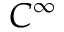Convert formula to latex. <formula><loc_0><loc_0><loc_500><loc_500>C ^ { \infty }</formula> 